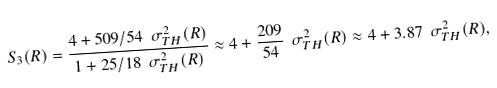<formula> <loc_0><loc_0><loc_500><loc_500>S _ { 3 } ( R ) = \frac { 4 + 5 0 9 / 5 4 \ \sigma ^ { 2 } _ { T H } ( R ) } { 1 + 2 5 / 1 8 \ \sigma ^ { 2 } _ { T H } ( R ) } \approx 4 + \frac { 2 0 9 } { 5 4 } \ \sigma ^ { 2 } _ { T H } ( R ) \approx 4 + 3 . 8 7 \ \sigma ^ { 2 } _ { T H } ( R ) ,</formula> 